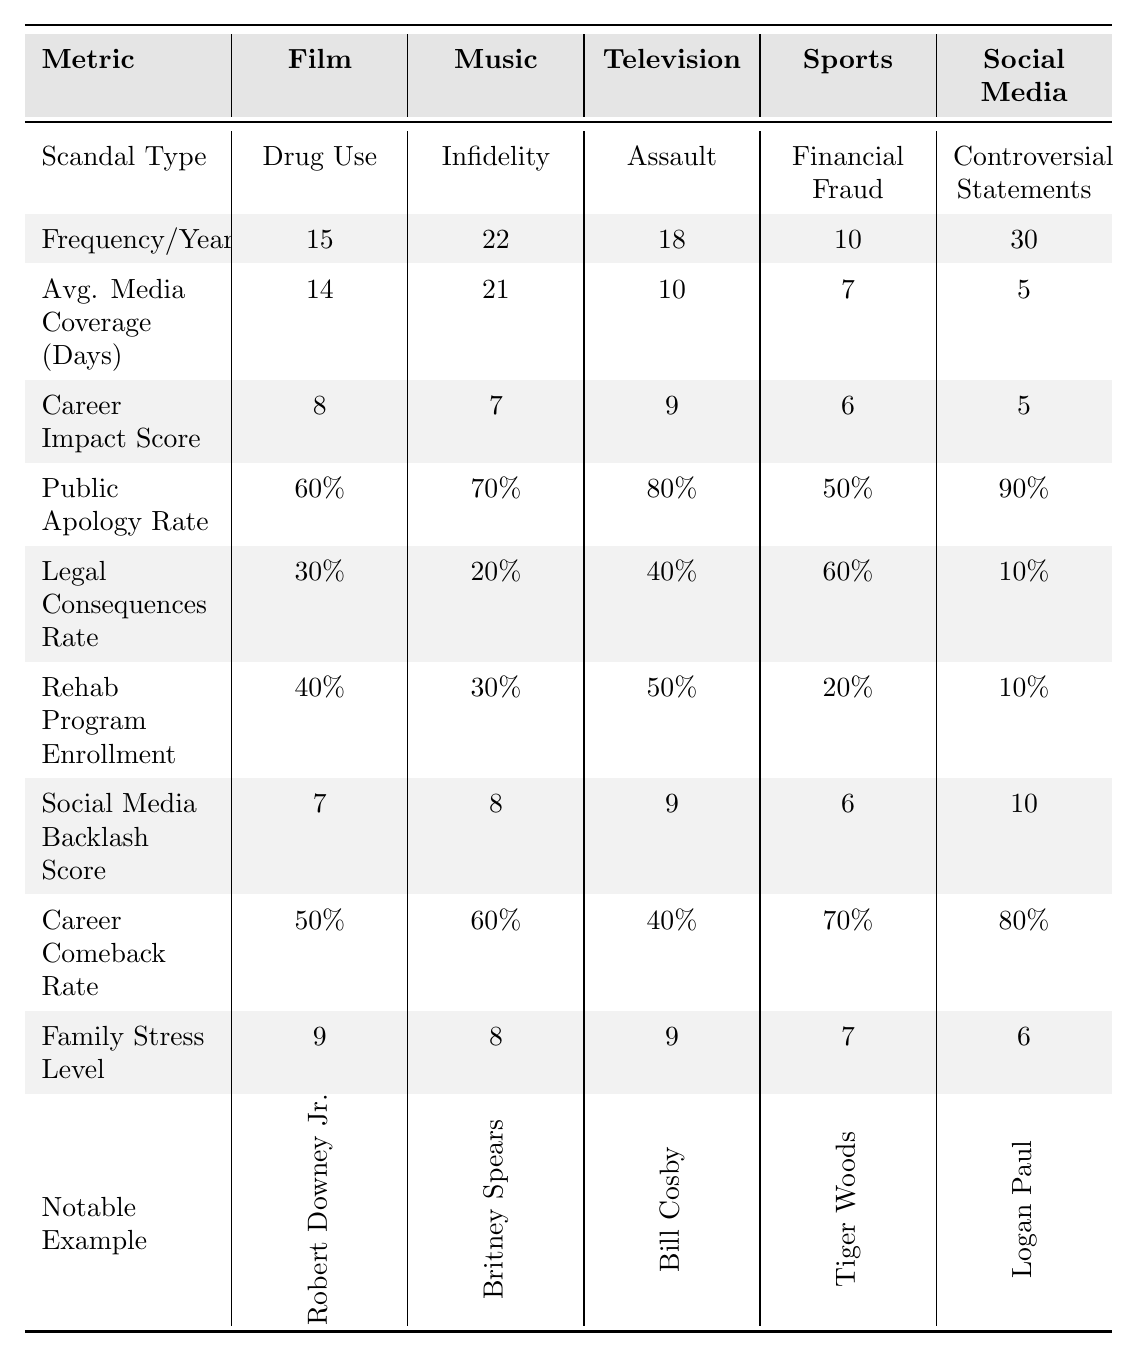What is the most common scandal type in the music industry? The table shows that the most common scandal type in the music industry is infidelity, which corresponds to the provided data.
Answer: Infidelity Which industry has the highest average media coverage days for scandals? The table lists the average media coverage days per industry. Music has the highest coverage with 21 days.
Answer: Music What is the frequency of drug use scandals in the film industry per year? According to the table, the film industry experiences 15 drug use scandals each year.
Answer: 15 What percentage of scandals in social media result in public apologies? The table states that 90% of scandals in social media result in public apologies.
Answer: 90% Which industry has the lowest career impact score based on scandals? By examining the career impact scores, social media has the lowest score at 5.
Answer: Social Media If you combine the frequencies of scandals for film and sports, what is the total? The frequency of scandals in film is 15 and in sports is 10. Adding them together gives 15 + 10 = 25.
Answer: 25 Is the legal consequences rate higher for television scandals compared to social media scandals? The legal consequences rate is 40% for television and 10% for social media, so television has a higher rate.
Answer: Yes What is the relationship between the average media coverage days and the scandal frequency for the sports industry? The average media coverage days for sports is 7 days, and the frequency of scandals is 10 per year, suggesting less coverage relative to the frequency.
Answer: Less coverage relative to frequency How does the family stress level differ between music and social media scandals? The family stress level for music is 8, while for social media, it is 6, indicating that music scandals create more family stress.
Answer: Higher for music Considering the rehabilitation program enrollment, which industry has the least participation? The rehabilitation program enrollment is lowest in social media at 10%.
Answer: Social Media 